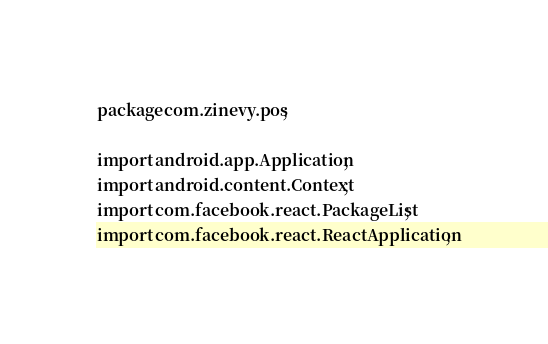Convert code to text. <code><loc_0><loc_0><loc_500><loc_500><_Java_>package com.zinevy.pos;

import android.app.Application;
import android.content.Context;
import com.facebook.react.PackageList;
import com.facebook.react.ReactApplication;</code> 